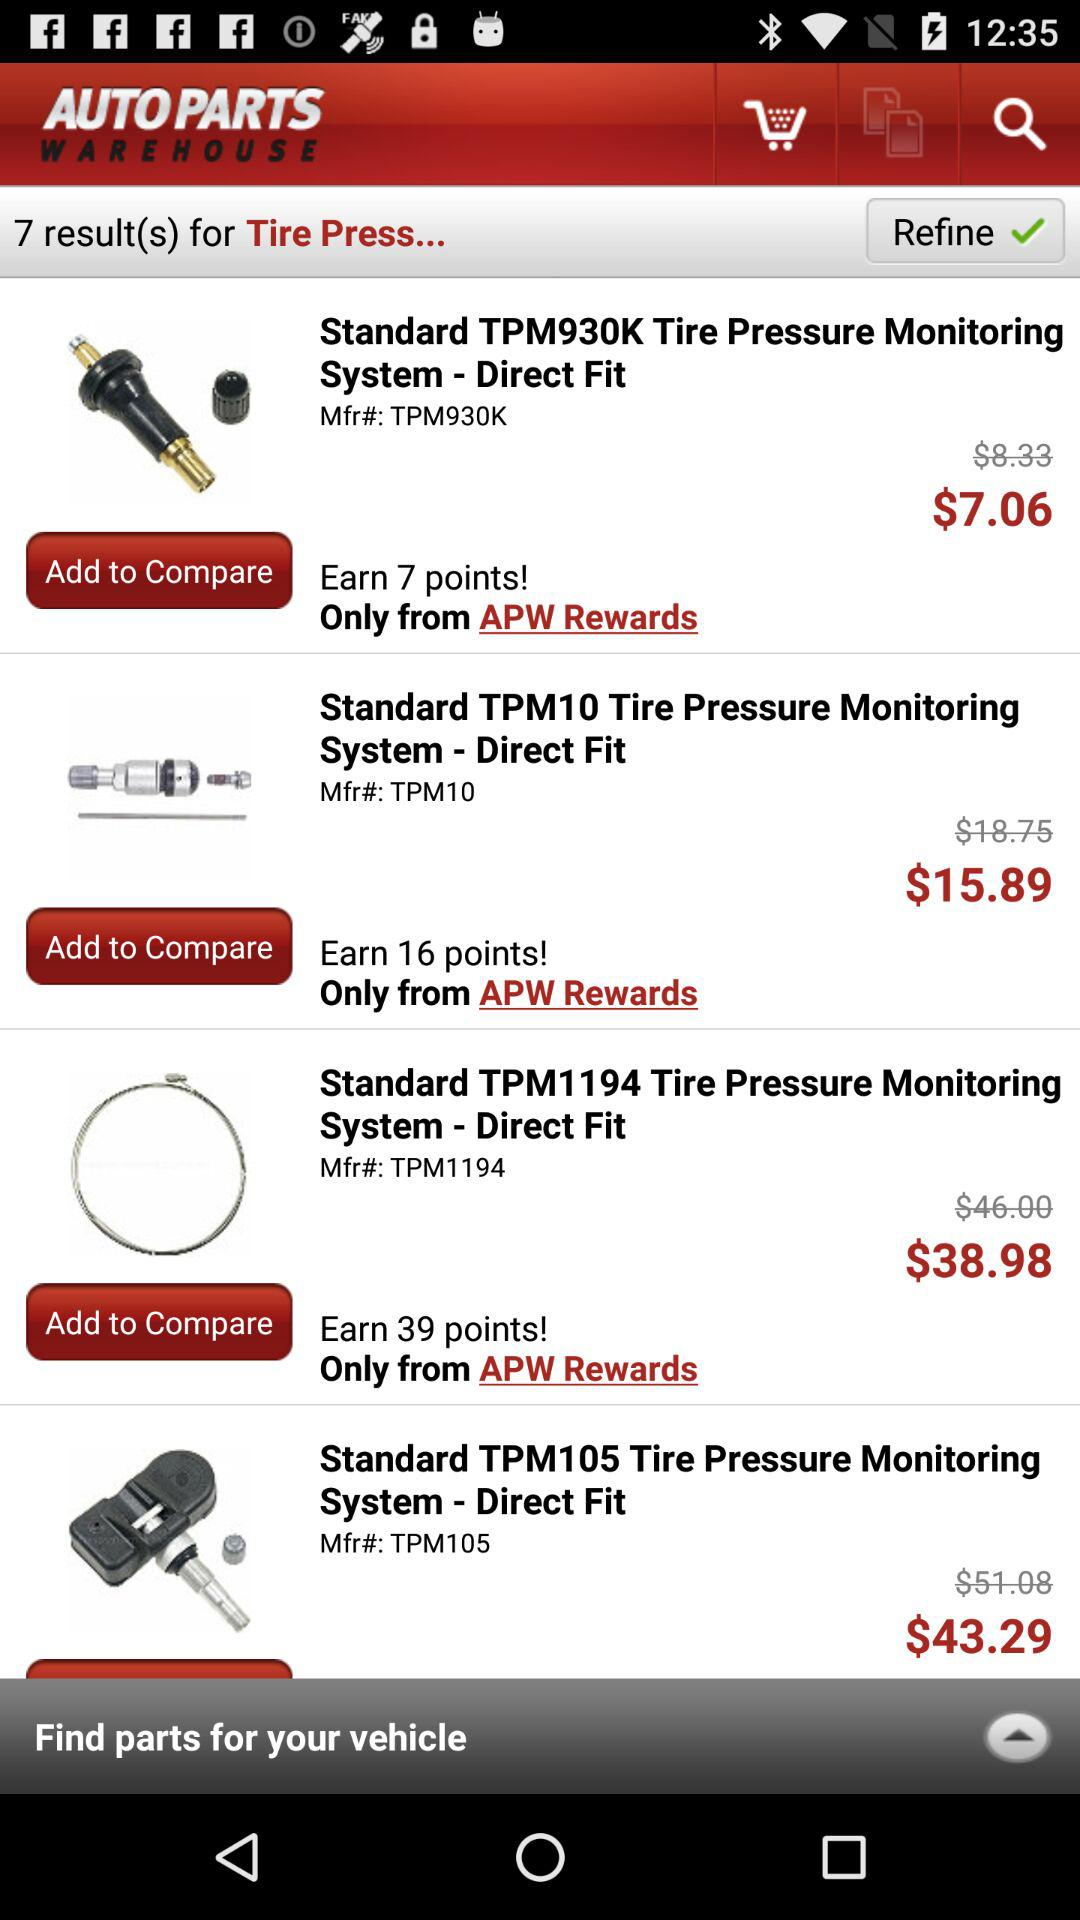What is the price of the standard TPM10 tire pressure monitoring system-direct fit?
Answer the question using a single word or phrase. The price is $15.89 